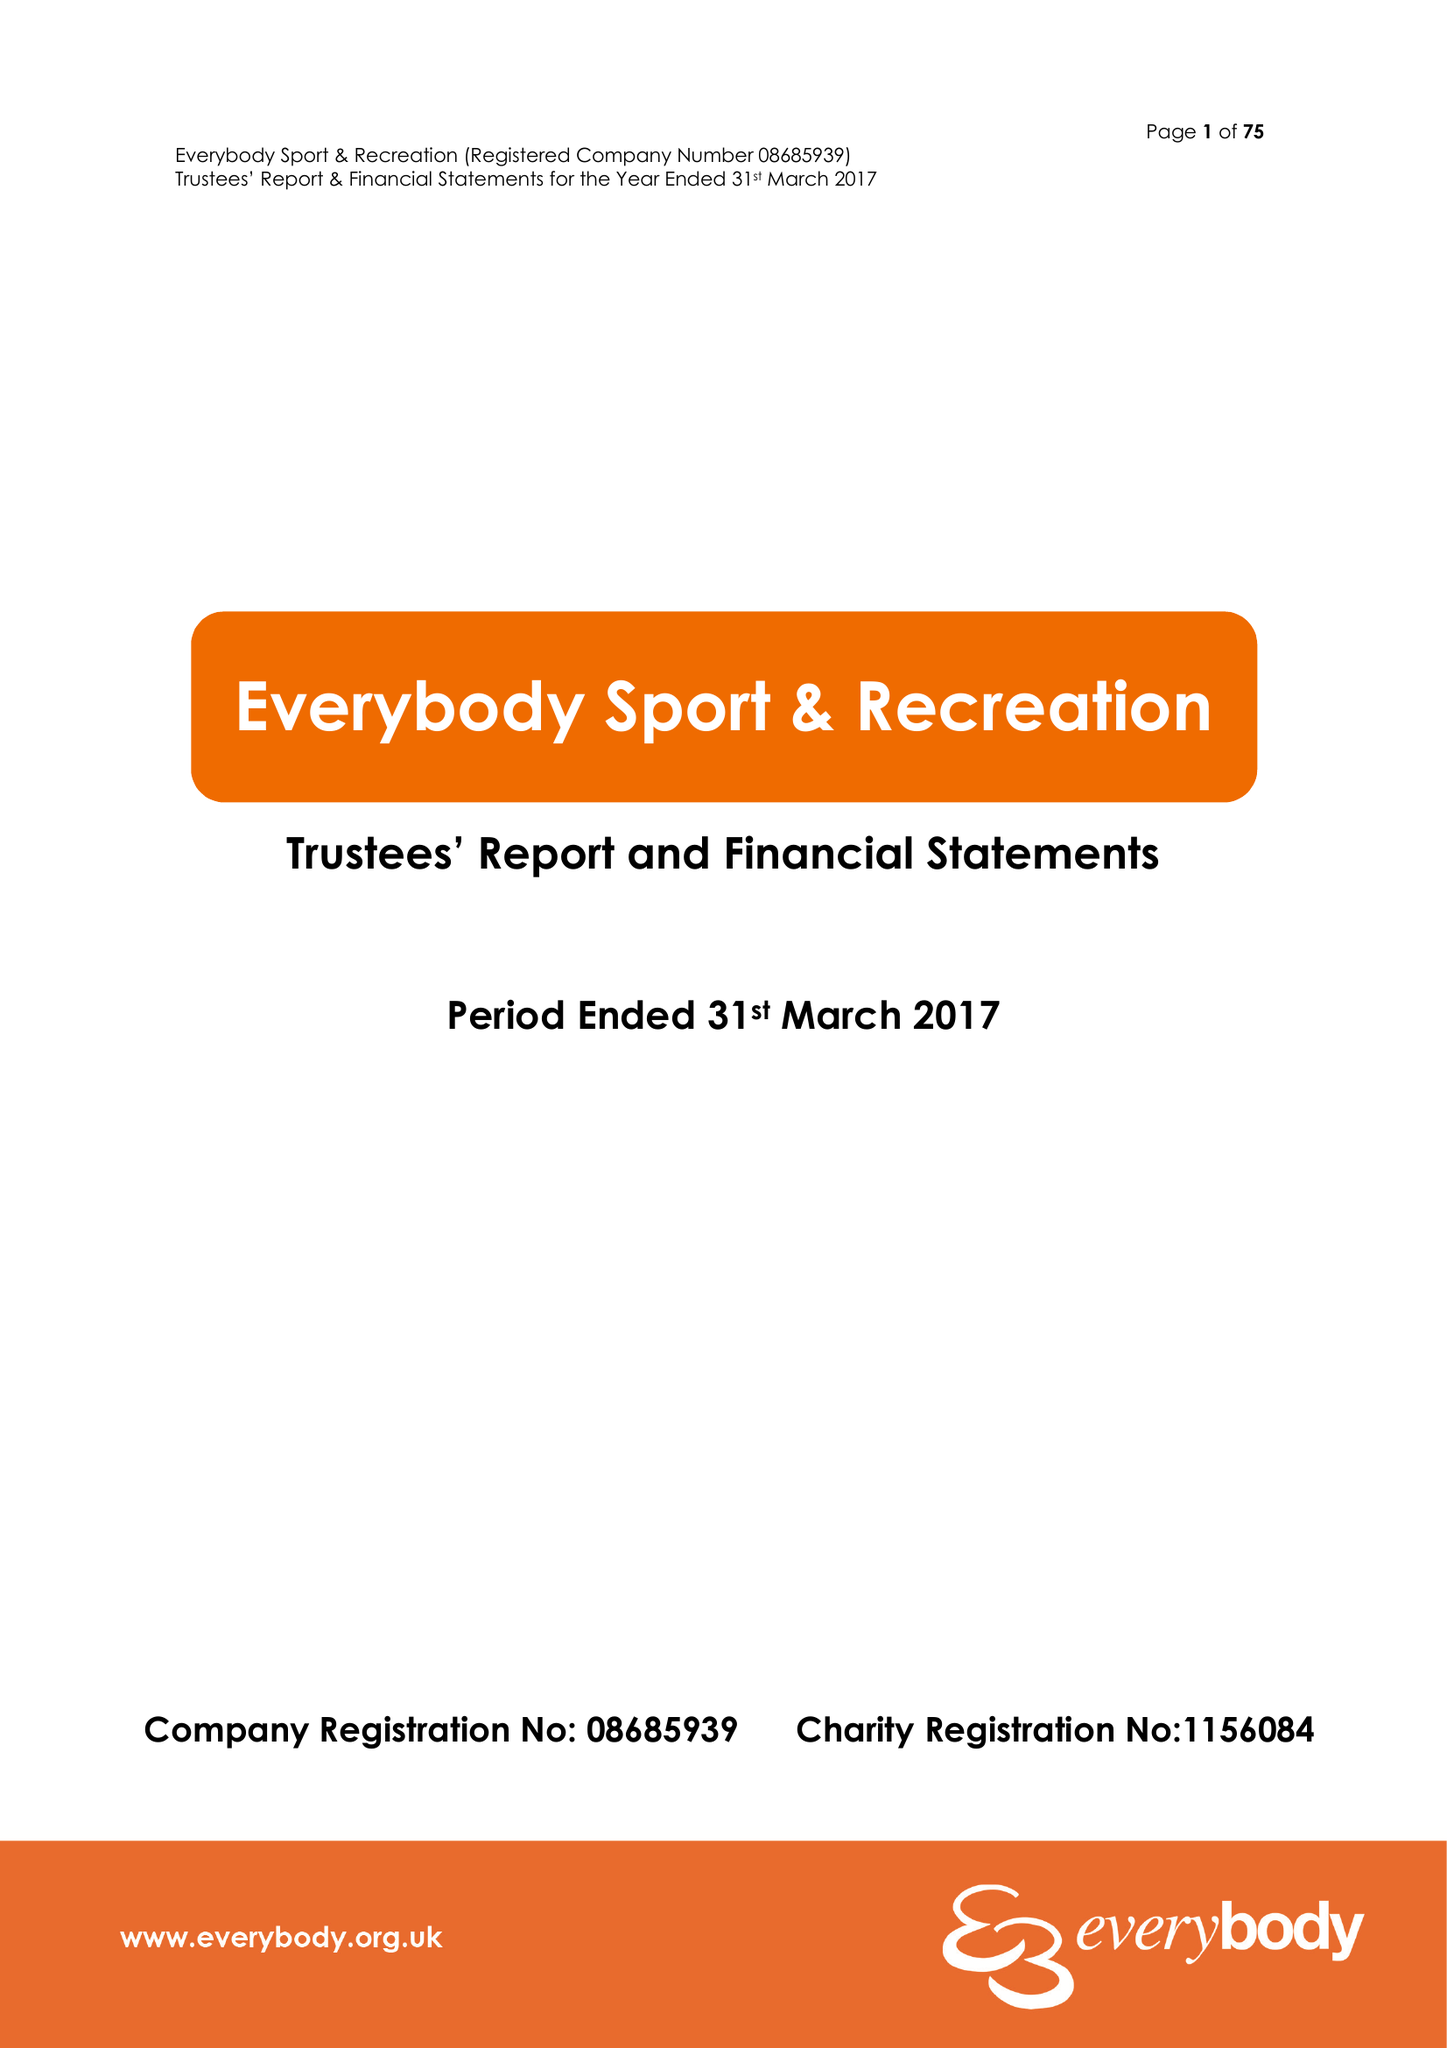What is the value for the charity_name?
Answer the question using a single word or phrase. Everybody Sport and Recreation 